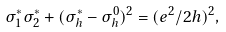Convert formula to latex. <formula><loc_0><loc_0><loc_500><loc_500>\sigma ^ { * } _ { 1 } \sigma ^ { * } _ { 2 } + ( \sigma ^ { * } _ { h } - \sigma _ { h } ^ { 0 } ) ^ { 2 } = ( e ^ { 2 } / 2 h ) ^ { 2 } ,</formula> 